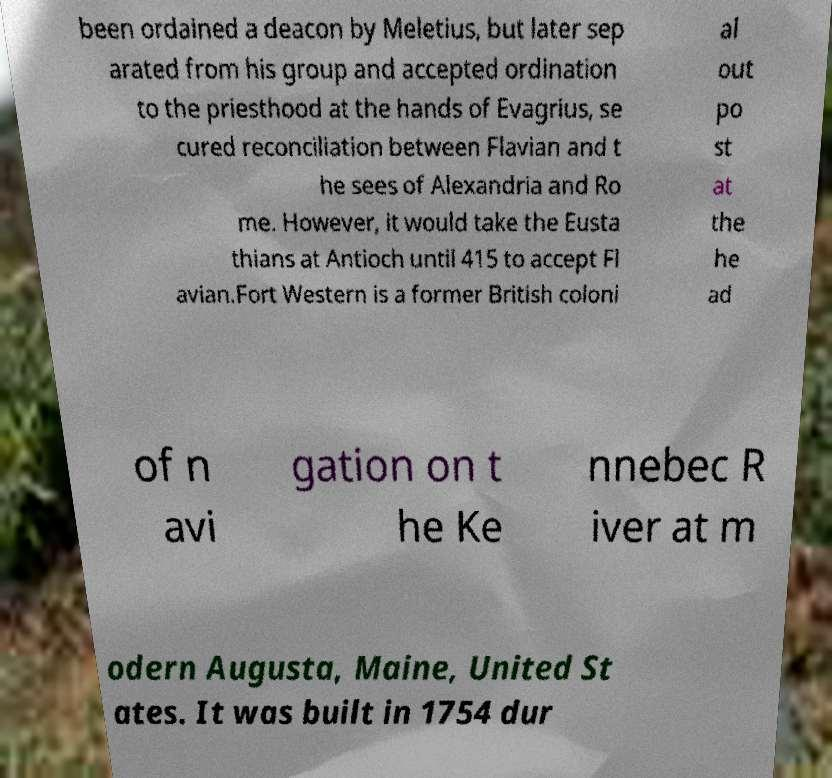Could you assist in decoding the text presented in this image and type it out clearly? been ordained a deacon by Meletius, but later sep arated from his group and accepted ordination to the priesthood at the hands of Evagrius, se cured reconciliation between Flavian and t he sees of Alexandria and Ro me. However, it would take the Eusta thians at Antioch until 415 to accept Fl avian.Fort Western is a former British coloni al out po st at the he ad of n avi gation on t he Ke nnebec R iver at m odern Augusta, Maine, United St ates. It was built in 1754 dur 